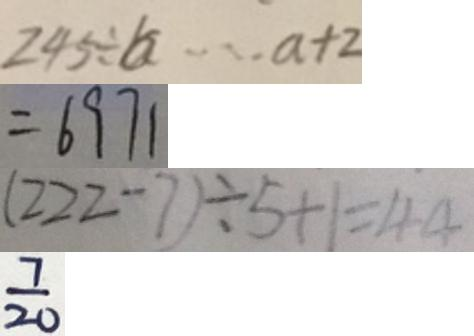<formula> <loc_0><loc_0><loc_500><loc_500>2 4 5 \div b \cdots a + 2 
 = 6 9 7 1 
 ( 2 2 2 - 7 ) \div 5 + 1 = 4 4 
 \frac { 7 } { 2 0 }</formula> 